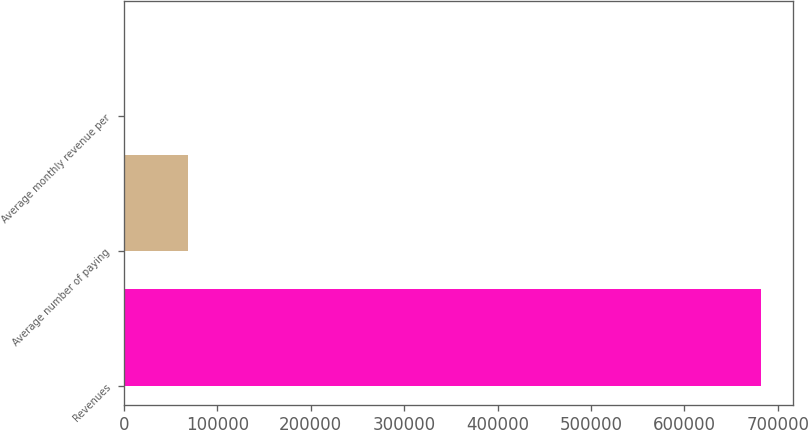<chart> <loc_0><loc_0><loc_500><loc_500><bar_chart><fcel>Revenues<fcel>Average number of paying<fcel>Average monthly revenue per<nl><fcel>682213<fcel>68237.4<fcel>17.94<nl></chart> 